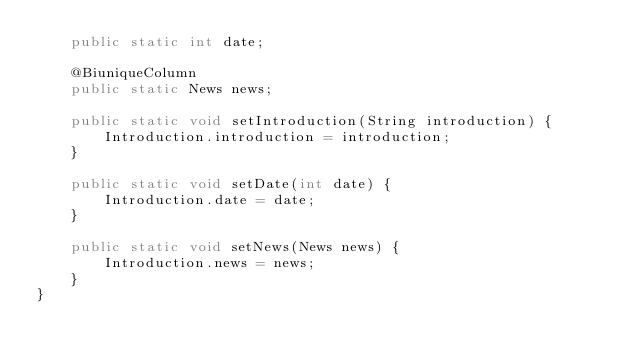<code> <loc_0><loc_0><loc_500><loc_500><_Java_>    public static int date;

    @BiuniqueColumn
    public static News news;

    public static void setIntroduction(String introduction) {
        Introduction.introduction = introduction;
    }

    public static void setDate(int date) {
        Introduction.date = date;
    }

    public static void setNews(News news) {
        Introduction.news = news;
    }
}
</code> 